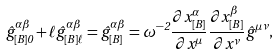Convert formula to latex. <formula><loc_0><loc_0><loc_500><loc_500>\hat { g } ^ { \alpha \beta } _ { [ B ] 0 } + \ell \hat { g } ^ { \alpha \beta } _ { [ B ] \ell } = \hat { g } ^ { \alpha \beta } _ { [ B ] } = \omega ^ { - 2 } \frac { \partial x ^ { \alpha } _ { [ B ] } } { \partial x ^ { \mu } } \frac { \partial x ^ { \beta } _ { [ B ] } } { \partial x ^ { \nu } } \hat { g } ^ { \mu \nu } ,</formula> 